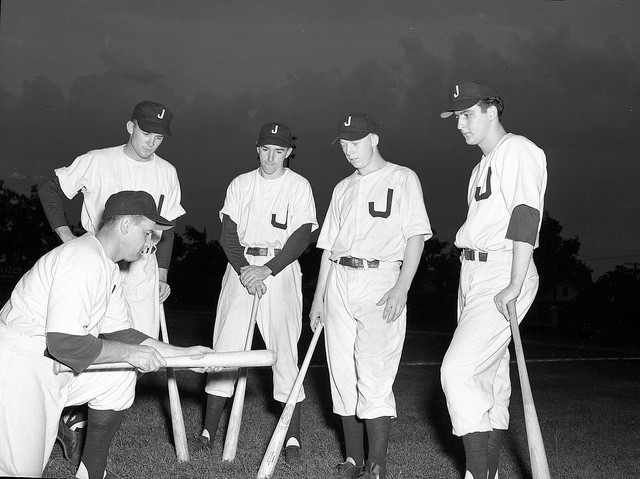Describe the objects in this image and their specific colors. I can see people in black, white, gray, and darkgray tones, people in black, lightgray, gray, and darkgray tones, people in black, white, gray, and darkgray tones, people in black, lightgray, gray, and darkgray tones, and people in black, lightgray, darkgray, and gray tones in this image. 